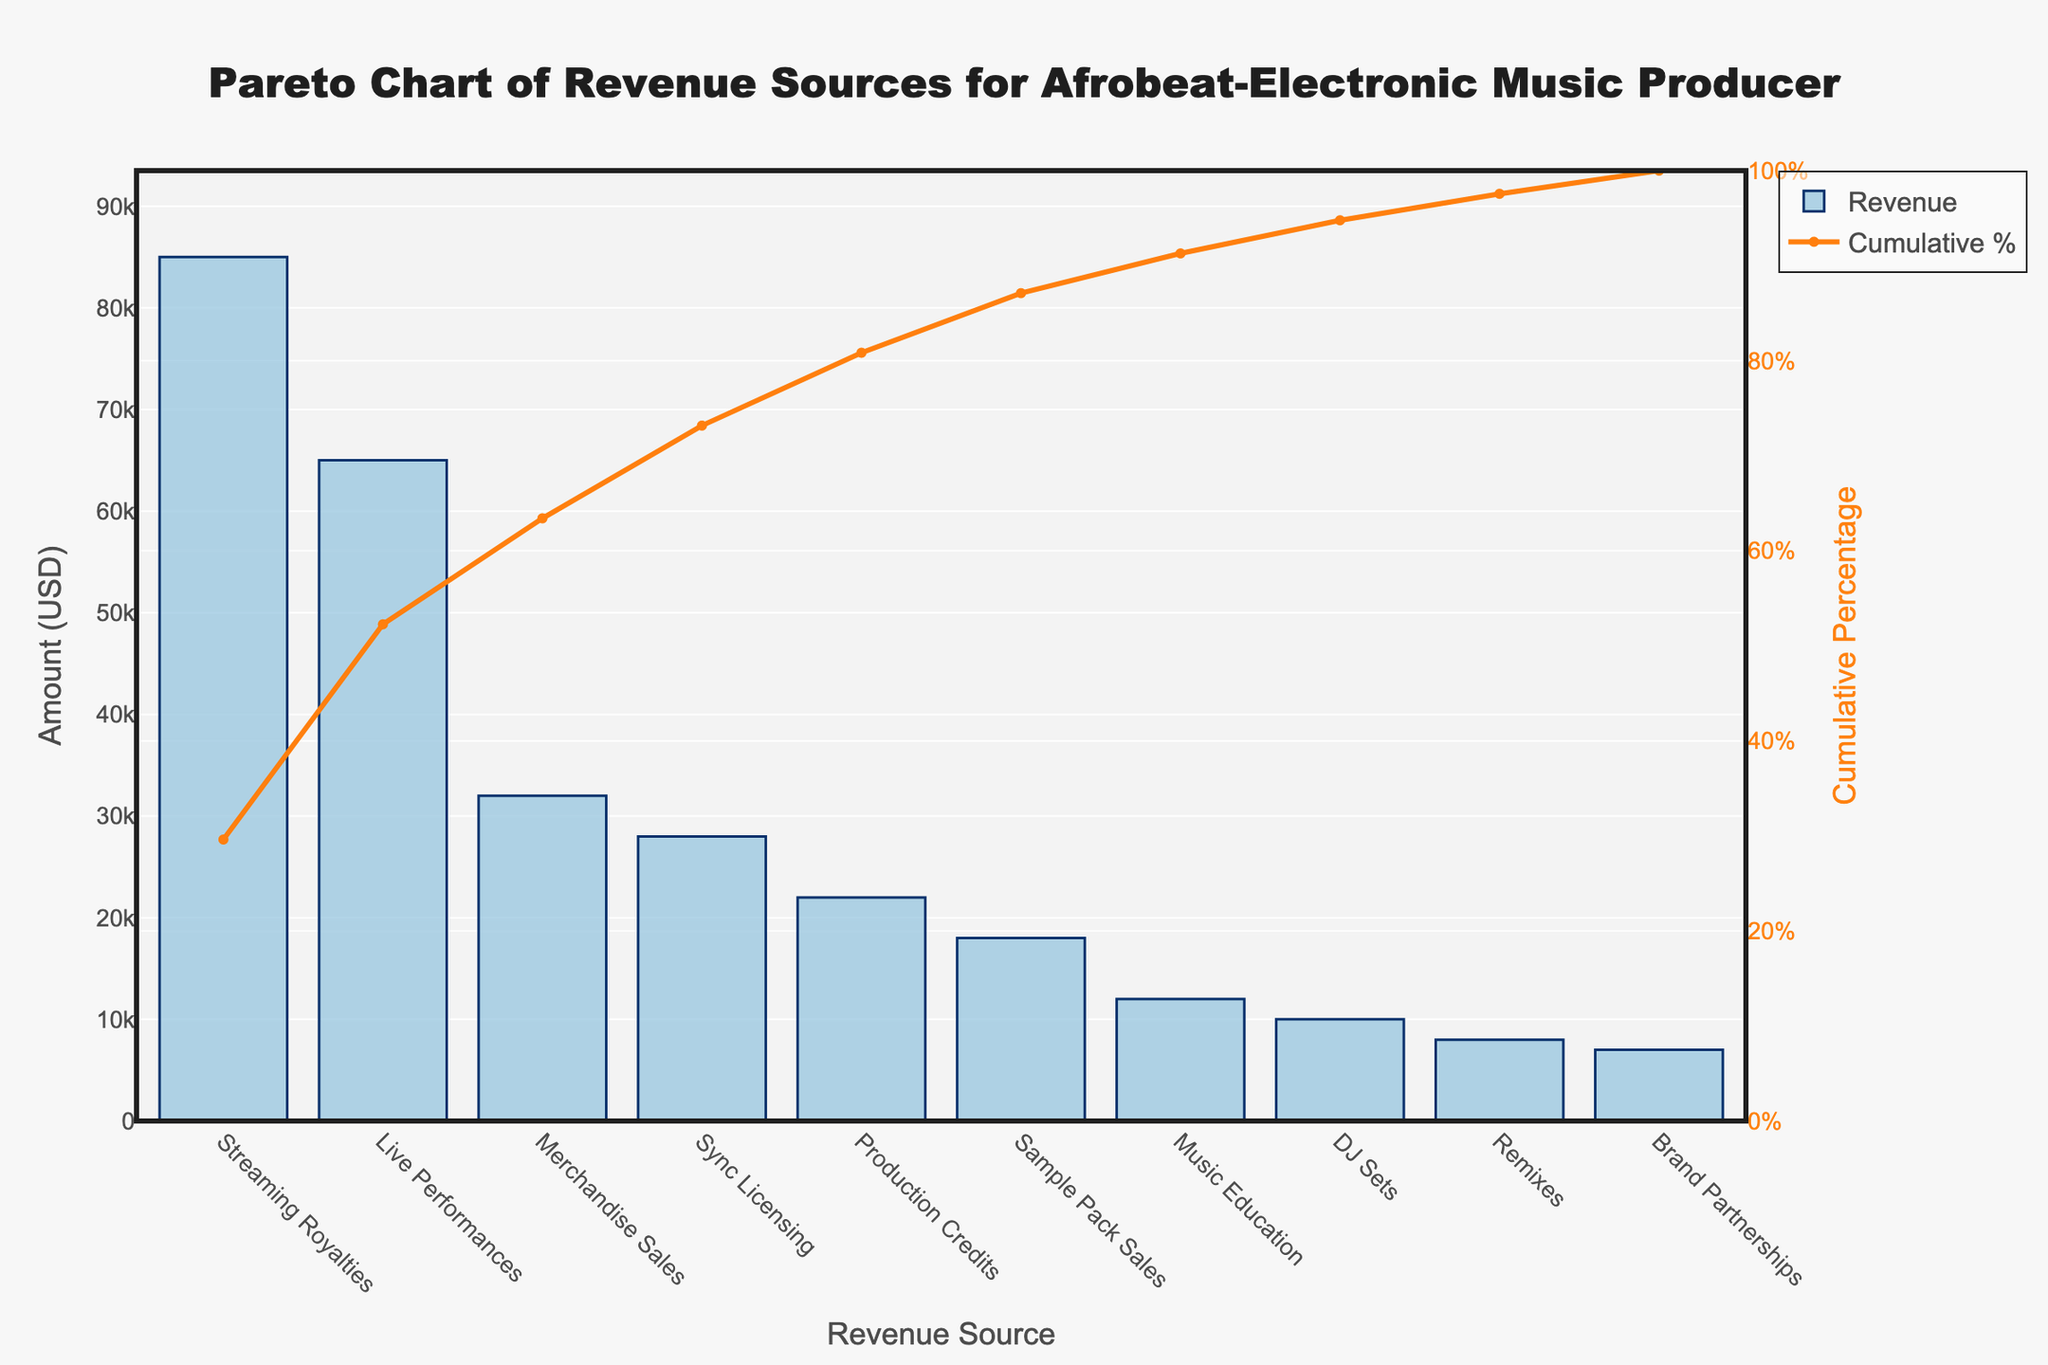What's the title of the chart? The title of the chart is displayed at the top.
Answer: Pareto Chart of Revenue Sources for Afrobeat-Electronic Music Producer What is the highest revenue source? The highest bar on the chart represents the largest revenue source.
Answer: Streaming Royalties What is the cumulative percentage at the third revenue source? Identify the third bar and its corresponding line plot value.
Answer: 71.1% How many revenue sources contribute more than $20,000? Count the number of bars with heights greater than $20,000.
Answer: 4 Which revenue source is just below Merchandise Sales in terms of revenue? Look at the bar immediately lower than the Merchandise Sales' bar.
Answer: Sync Licensing What's the cumulative percentage after the top four revenue sources? Sum the cumulative percentages of the first four bars.
Answer: 81.8% How much more revenue does Streaming Royalties generate compared to Production Credits? Subtract the amount of Production Credits from Streaming Royalties.
Answer: $63,000 What percentage of the total revenue is contributed by Streaming Royalties and Live Performances combined? Add the two amounts and divide by the total revenue, then multiply by 100.
Answer: 61.1% Which revenue source has the lowest amount? The shortest bar represents the lowest revenue source.
Answer: Brand Partnerships What is the range of the cumulative percentage axis on the right? Check the labels on the right y-axis.
Answer: 0% to 100% 